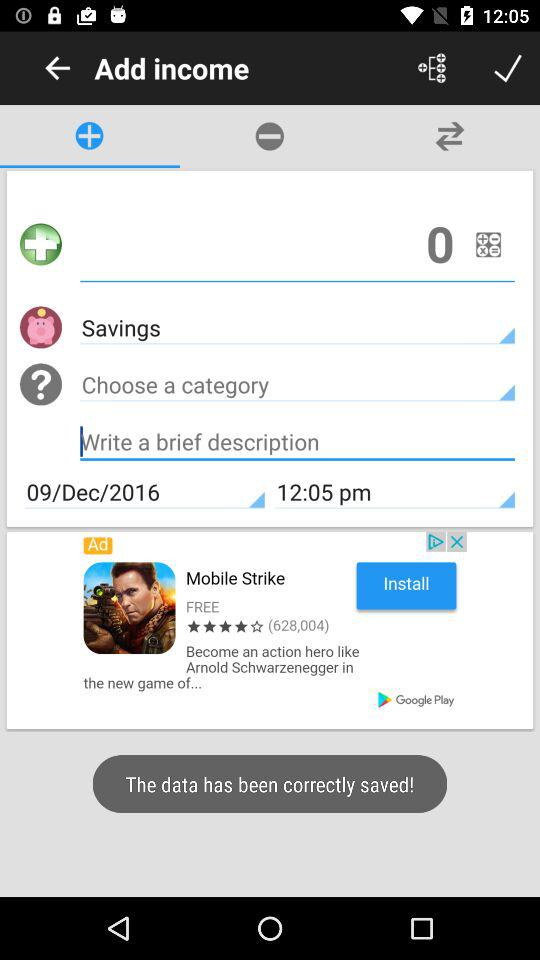What is the mentioned date? The mentioned date is December 9, 2016. 